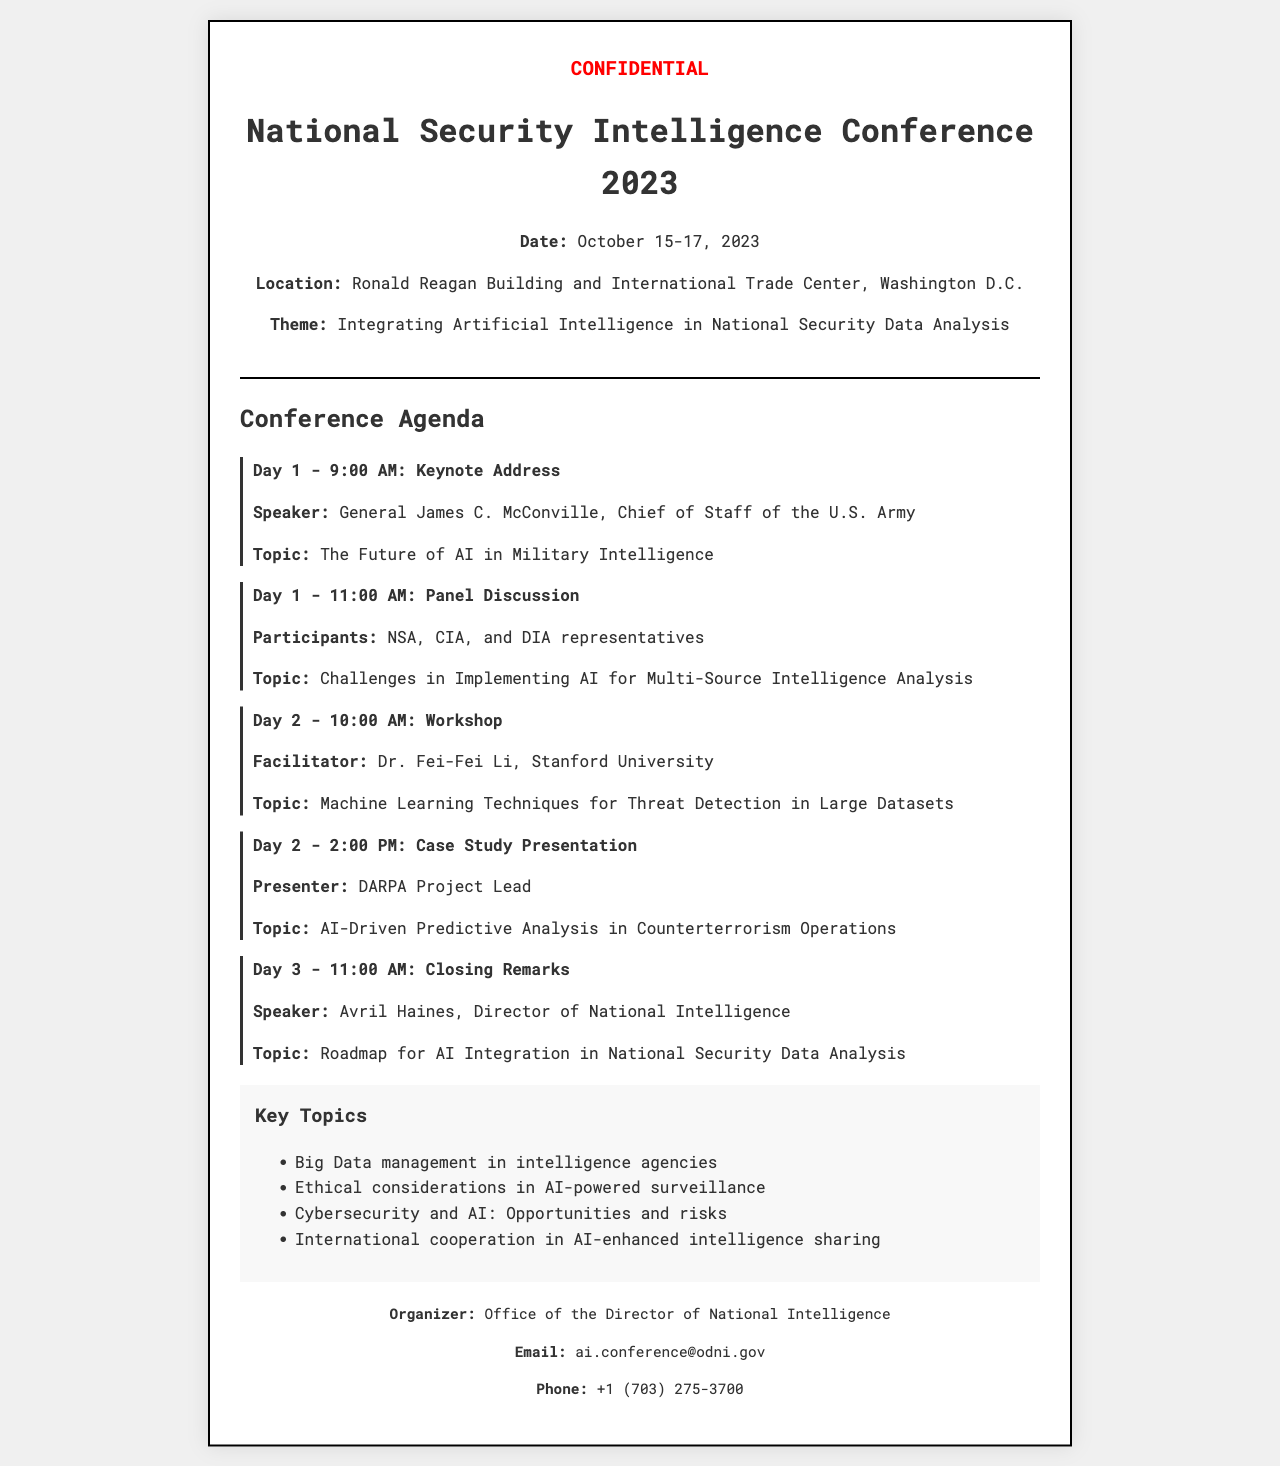What is the date of the conference? The date is mentioned in the conference details section of the document.
Answer: October 15-17, 2023 Who is the keynote speaker? The keynote speaker is specified in the agenda for Day 1.
Answer: General James C. McConville What topic will be discussed in the panel discussion? The topic is indicated alongside the participants for Day 1's panel discussion.
Answer: Challenges in Implementing AI for Multi-Source Intelligence Analysis Who is facilitating the workshop on Day 2? The facilitator's name is provided in the description of the workshop.
Answer: Dr. Fei-Fei Li What are the key topics listed in the document? The key topics are enumerated in a specific section of the document.
Answer: Big Data management in intelligence agencies What is the closing remarks speaker’s title? The title is mentioned alongside the speaker's name in the closing remarks section.
Answer: Director of National Intelligence What is the location of the conference? The location is provided in the conference details section.
Answer: Ronald Reagan Building and International Trade Center, Washington D.C What is the theme of the conference? The theme is specified in the conference details section.
Answer: Integrating Artificial Intelligence in National Security Data Analysis Who organized the conference? The organizer's information can be found at the end of the document.
Answer: Office of the Director of National Intelligence 